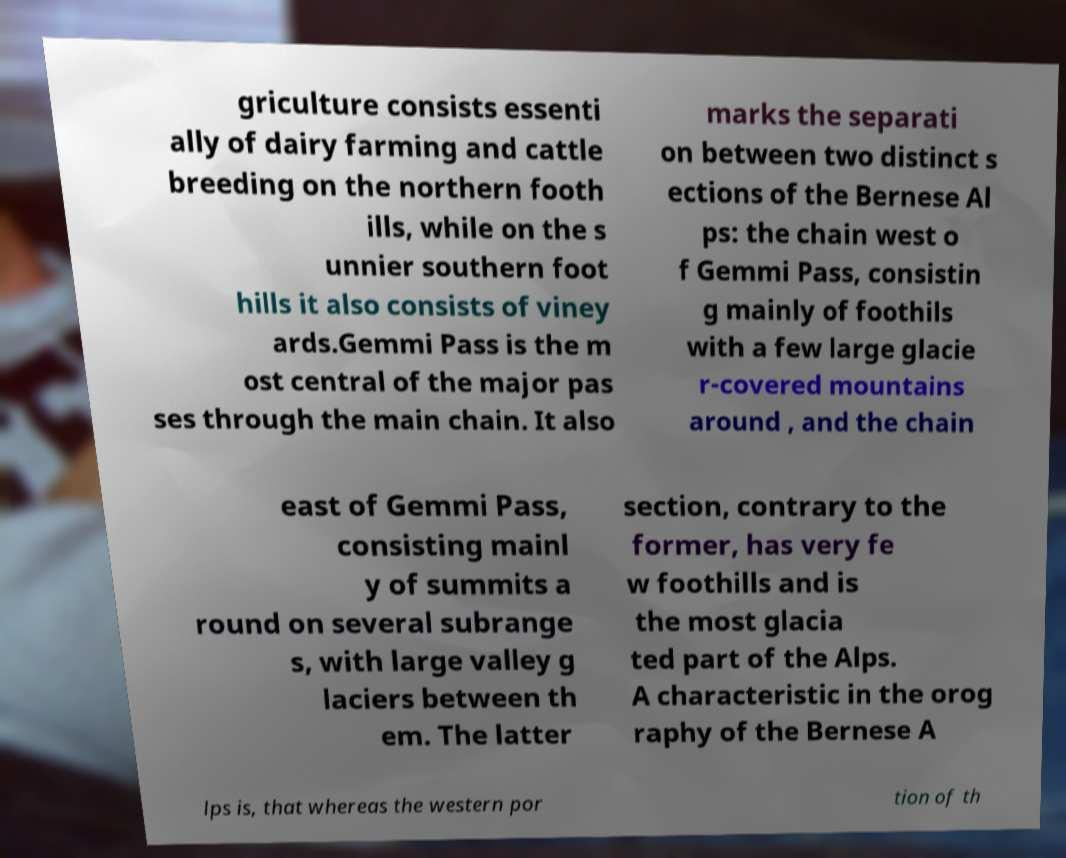What messages or text are displayed in this image? I need them in a readable, typed format. griculture consists essenti ally of dairy farming and cattle breeding on the northern footh ills, while on the s unnier southern foot hills it also consists of viney ards.Gemmi Pass is the m ost central of the major pas ses through the main chain. It also marks the separati on between two distinct s ections of the Bernese Al ps: the chain west o f Gemmi Pass, consistin g mainly of foothils with a few large glacie r-covered mountains around , and the chain east of Gemmi Pass, consisting mainl y of summits a round on several subrange s, with large valley g laciers between th em. The latter section, contrary to the former, has very fe w foothills and is the most glacia ted part of the Alps. A characteristic in the orog raphy of the Bernese A lps is, that whereas the western por tion of th 